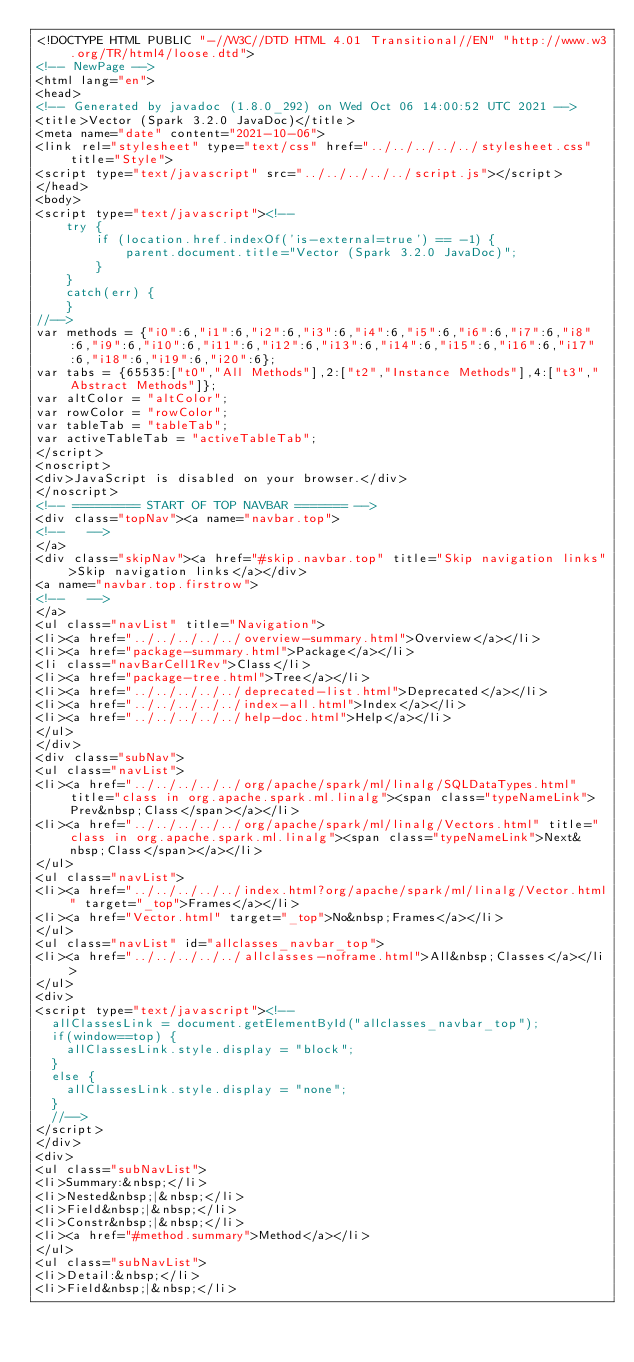Convert code to text. <code><loc_0><loc_0><loc_500><loc_500><_HTML_><!DOCTYPE HTML PUBLIC "-//W3C//DTD HTML 4.01 Transitional//EN" "http://www.w3.org/TR/html4/loose.dtd">
<!-- NewPage -->
<html lang="en">
<head>
<!-- Generated by javadoc (1.8.0_292) on Wed Oct 06 14:00:52 UTC 2021 -->
<title>Vector (Spark 3.2.0 JavaDoc)</title>
<meta name="date" content="2021-10-06">
<link rel="stylesheet" type="text/css" href="../../../../../stylesheet.css" title="Style">
<script type="text/javascript" src="../../../../../script.js"></script>
</head>
<body>
<script type="text/javascript"><!--
    try {
        if (location.href.indexOf('is-external=true') == -1) {
            parent.document.title="Vector (Spark 3.2.0 JavaDoc)";
        }
    }
    catch(err) {
    }
//-->
var methods = {"i0":6,"i1":6,"i2":6,"i3":6,"i4":6,"i5":6,"i6":6,"i7":6,"i8":6,"i9":6,"i10":6,"i11":6,"i12":6,"i13":6,"i14":6,"i15":6,"i16":6,"i17":6,"i18":6,"i19":6,"i20":6};
var tabs = {65535:["t0","All Methods"],2:["t2","Instance Methods"],4:["t3","Abstract Methods"]};
var altColor = "altColor";
var rowColor = "rowColor";
var tableTab = "tableTab";
var activeTableTab = "activeTableTab";
</script>
<noscript>
<div>JavaScript is disabled on your browser.</div>
</noscript>
<!-- ========= START OF TOP NAVBAR ======= -->
<div class="topNav"><a name="navbar.top">
<!--   -->
</a>
<div class="skipNav"><a href="#skip.navbar.top" title="Skip navigation links">Skip navigation links</a></div>
<a name="navbar.top.firstrow">
<!--   -->
</a>
<ul class="navList" title="Navigation">
<li><a href="../../../../../overview-summary.html">Overview</a></li>
<li><a href="package-summary.html">Package</a></li>
<li class="navBarCell1Rev">Class</li>
<li><a href="package-tree.html">Tree</a></li>
<li><a href="../../../../../deprecated-list.html">Deprecated</a></li>
<li><a href="../../../../../index-all.html">Index</a></li>
<li><a href="../../../../../help-doc.html">Help</a></li>
</ul>
</div>
<div class="subNav">
<ul class="navList">
<li><a href="../../../../../org/apache/spark/ml/linalg/SQLDataTypes.html" title="class in org.apache.spark.ml.linalg"><span class="typeNameLink">Prev&nbsp;Class</span></a></li>
<li><a href="../../../../../org/apache/spark/ml/linalg/Vectors.html" title="class in org.apache.spark.ml.linalg"><span class="typeNameLink">Next&nbsp;Class</span></a></li>
</ul>
<ul class="navList">
<li><a href="../../../../../index.html?org/apache/spark/ml/linalg/Vector.html" target="_top">Frames</a></li>
<li><a href="Vector.html" target="_top">No&nbsp;Frames</a></li>
</ul>
<ul class="navList" id="allclasses_navbar_top">
<li><a href="../../../../../allclasses-noframe.html">All&nbsp;Classes</a></li>
</ul>
<div>
<script type="text/javascript"><!--
  allClassesLink = document.getElementById("allclasses_navbar_top");
  if(window==top) {
    allClassesLink.style.display = "block";
  }
  else {
    allClassesLink.style.display = "none";
  }
  //-->
</script>
</div>
<div>
<ul class="subNavList">
<li>Summary:&nbsp;</li>
<li>Nested&nbsp;|&nbsp;</li>
<li>Field&nbsp;|&nbsp;</li>
<li>Constr&nbsp;|&nbsp;</li>
<li><a href="#method.summary">Method</a></li>
</ul>
<ul class="subNavList">
<li>Detail:&nbsp;</li>
<li>Field&nbsp;|&nbsp;</li></code> 